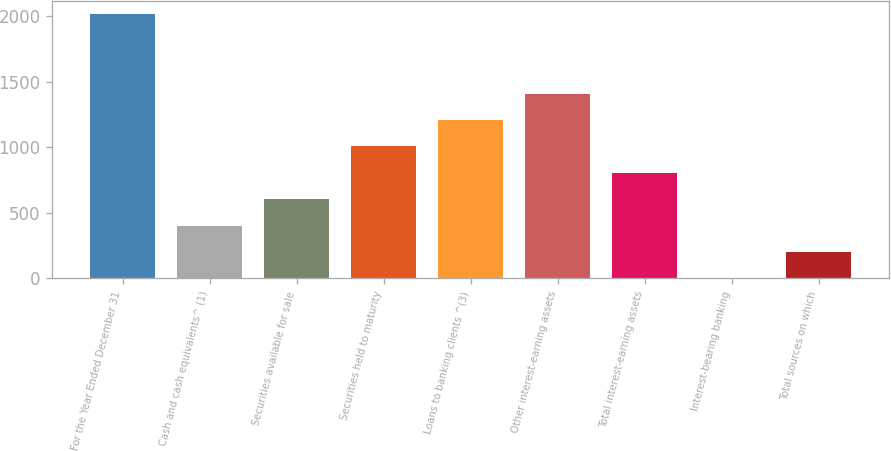Convert chart to OTSL. <chart><loc_0><loc_0><loc_500><loc_500><bar_chart><fcel>For the Year Ended December 31<fcel>Cash and cash equivalents^ (1)<fcel>Securities available for sale<fcel>Securities held to maturity<fcel>Loans to banking clients ^(3)<fcel>Other interest-earning assets<fcel>Total interest-earning assets<fcel>Interest-bearing banking<fcel>Total sources on which<nl><fcel>2013<fcel>402.64<fcel>603.94<fcel>1006.54<fcel>1207.84<fcel>1409.14<fcel>805.24<fcel>0.04<fcel>201.34<nl></chart> 